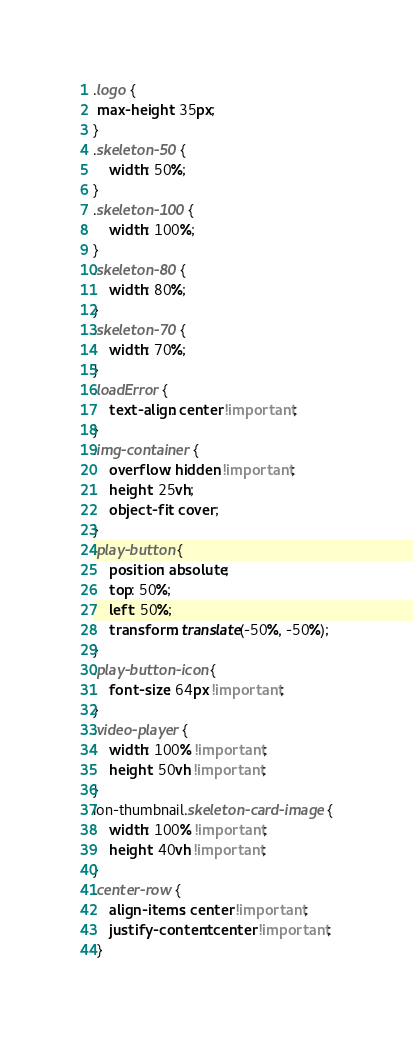<code> <loc_0><loc_0><loc_500><loc_500><_CSS_>.logo {
 max-height: 35px;
}
.skeleton-50 {
    width: 50%;
}
.skeleton-100 {
    width: 100%;
}
.skeleton-80 {
    width: 80%;
}
.skeleton-70 {
    width: 70%;
}
.loadError {
    text-align: center !important;
}
.img-container {
    overflow: hidden !important;
    height: 25vh;
    object-fit: cover;
}
.play-button {
    position: absolute;
    top: 50%;
    left: 50%;
    transform: translate(-50%, -50%);
}
.play-button-icon {
    font-size: 64px !important;
}
.video-player {
    width: 100% !important;
    height: 50vh !important;
}
ion-thumbnail.skeleton-card-image {
    width: 100% !important;
    height: 40vh !important;
}
.center-row { 
    align-items: center !important;
    justify-content: center !important;
 }
</code> 